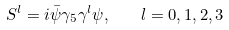Convert formula to latex. <formula><loc_0><loc_0><loc_500><loc_500>S ^ { l } = i \bar { \psi } \gamma _ { 5 } \gamma ^ { l } \psi , \quad l = 0 , 1 , 2 , 3</formula> 